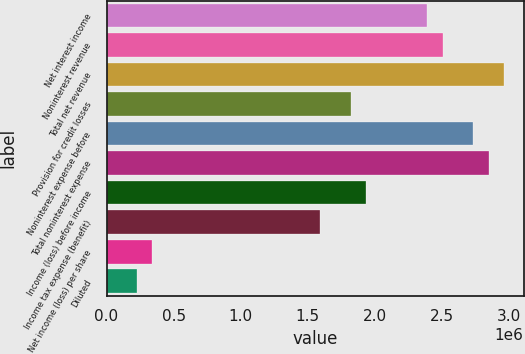<chart> <loc_0><loc_0><loc_500><loc_500><bar_chart><fcel>Net interest income<fcel>Noninterest revenue<fcel>Total net revenue<fcel>Provision for credit losses<fcel>Noninterest expense before<fcel>Total noninterest expense<fcel>Income (loss) before income<fcel>Income tax expense (benefit)<fcel>Net income (loss) per share<fcel>Diluted<nl><fcel>2.39078e+06<fcel>2.50463e+06<fcel>2.96002e+06<fcel>1.82155e+06<fcel>2.73233e+06<fcel>2.84617e+06<fcel>1.9354e+06<fcel>1.59386e+06<fcel>341541<fcel>227694<nl></chart> 